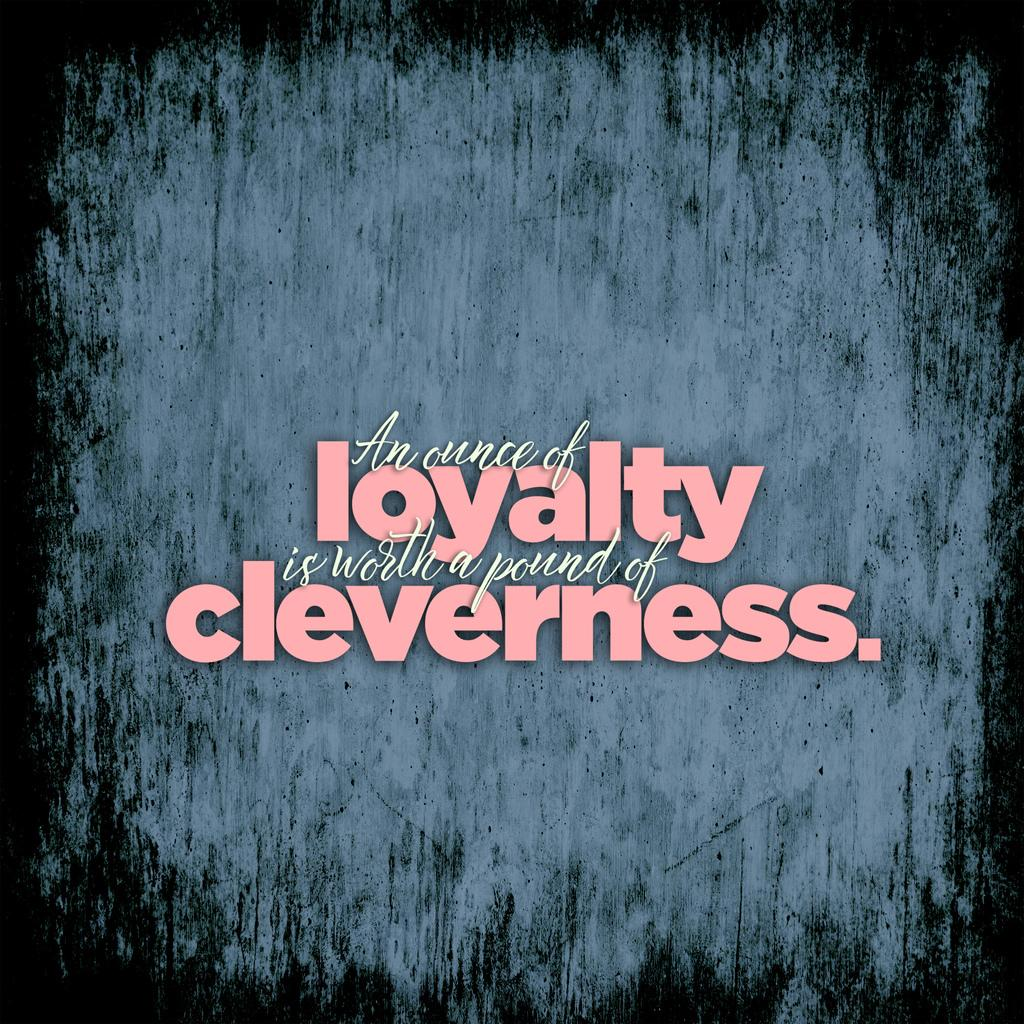Provide a one-sentence caption for the provided image. Sign that says an ounce of loyalty is worth a pound of cleverness. 